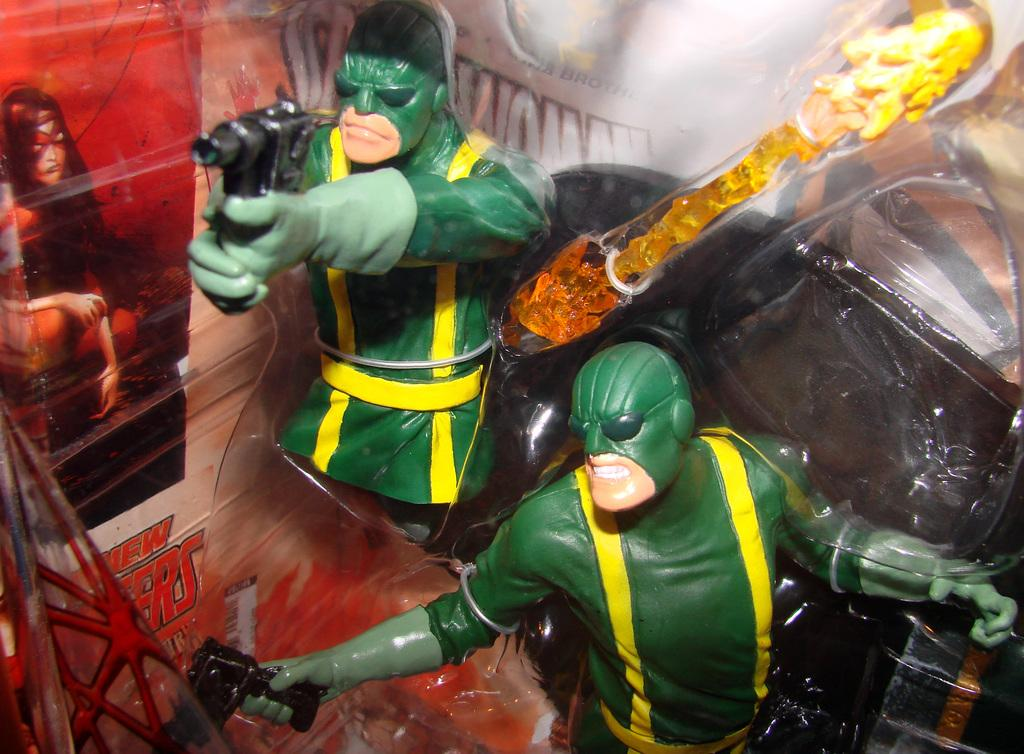What objects are in the image? There are toys in the image. Where are the toys located in the image? The toys are in the middle of the image. What can be seen on the left side of the image? There is a poster on the left side of the image. What type of crown is placed on the shelf in the image? There is no crown or shelf present in the image; it only features toys in the middle and a poster on the left side. 